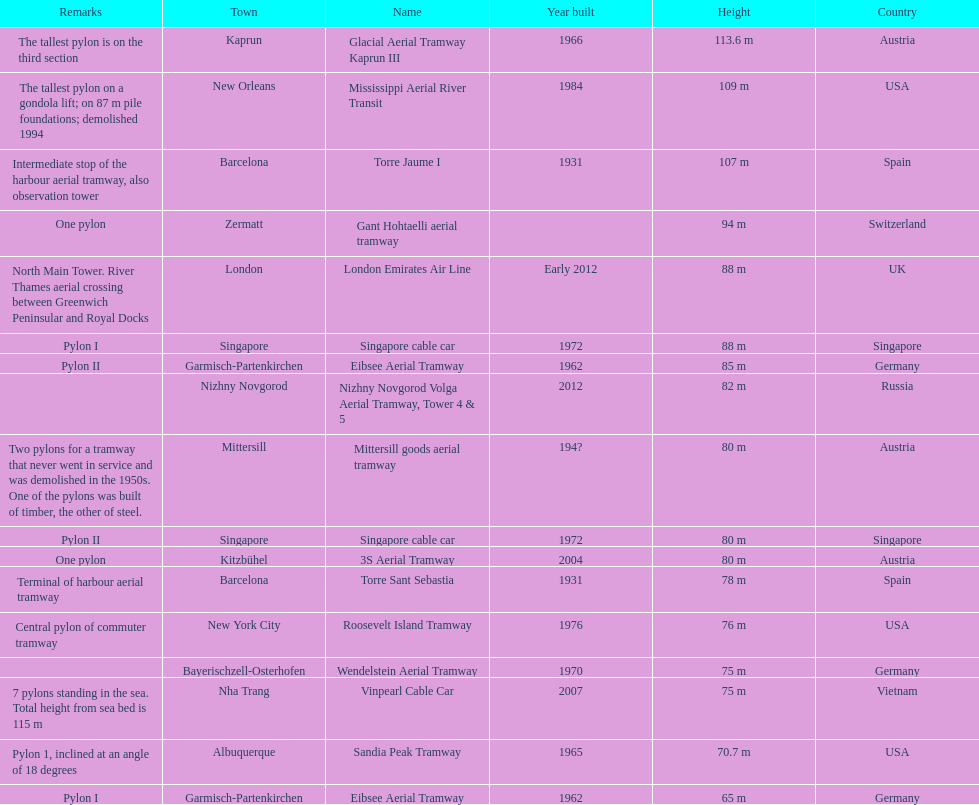List two pylons that are at most, 80 m in height. Mittersill goods aerial tramway, Singapore cable car. 